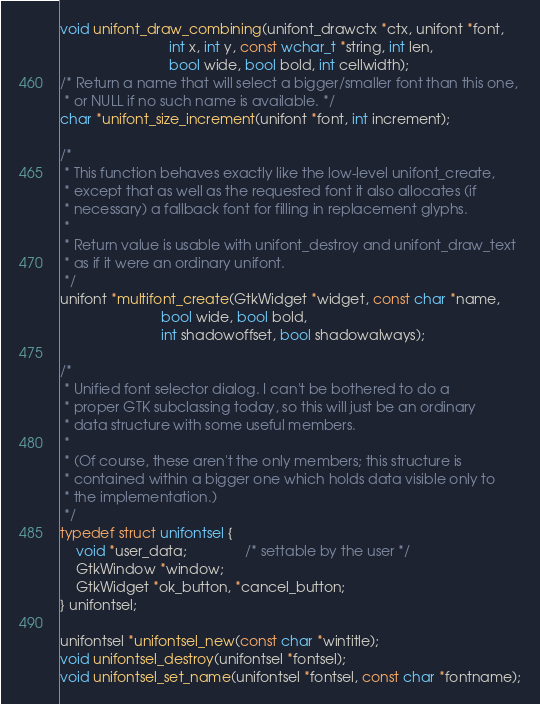<code> <loc_0><loc_0><loc_500><loc_500><_C_>void unifont_draw_combining(unifont_drawctx *ctx, unifont *font,
                            int x, int y, const wchar_t *string, int len,
                            bool wide, bool bold, int cellwidth);
/* Return a name that will select a bigger/smaller font than this one,
 * or NULL if no such name is available. */
char *unifont_size_increment(unifont *font, int increment);

/*
 * This function behaves exactly like the low-level unifont_create,
 * except that as well as the requested font it also allocates (if
 * necessary) a fallback font for filling in replacement glyphs.
 *
 * Return value is usable with unifont_destroy and unifont_draw_text
 * as if it were an ordinary unifont.
 */
unifont *multifont_create(GtkWidget *widget, const char *name,
                          bool wide, bool bold,
                          int shadowoffset, bool shadowalways);

/*
 * Unified font selector dialog. I can't be bothered to do a
 * proper GTK subclassing today, so this will just be an ordinary
 * data structure with some useful members.
 * 
 * (Of course, these aren't the only members; this structure is
 * contained within a bigger one which holds data visible only to
 * the implementation.)
 */
typedef struct unifontsel {
    void *user_data;		       /* settable by the user */
    GtkWindow *window;
    GtkWidget *ok_button, *cancel_button;
} unifontsel;

unifontsel *unifontsel_new(const char *wintitle);
void unifontsel_destroy(unifontsel *fontsel);
void unifontsel_set_name(unifontsel *fontsel, const char *fontname);</code> 